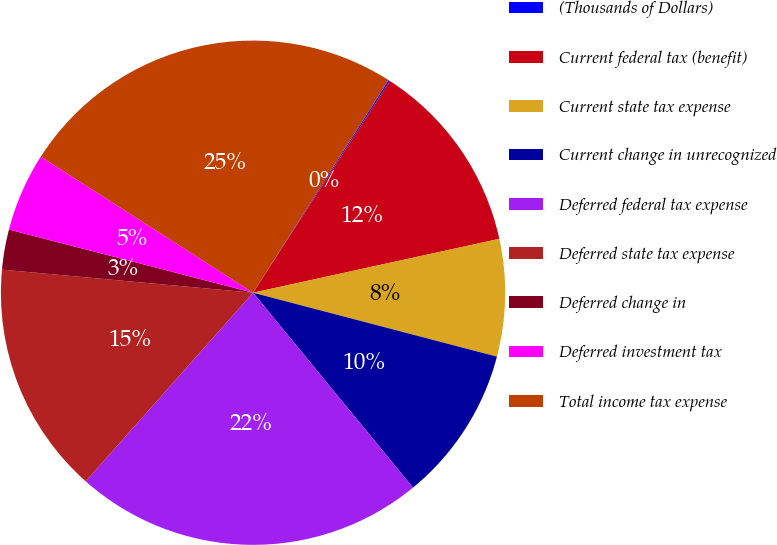<chart> <loc_0><loc_0><loc_500><loc_500><pie_chart><fcel>(Thousands of Dollars)<fcel>Current federal tax (benefit)<fcel>Current state tax expense<fcel>Current change in unrecognized<fcel>Deferred federal tax expense<fcel>Deferred state tax expense<fcel>Deferred change in<fcel>Deferred investment tax<fcel>Total income tax expense<nl><fcel>0.1%<fcel>12.44%<fcel>7.51%<fcel>9.98%<fcel>22.49%<fcel>14.91%<fcel>2.57%<fcel>5.04%<fcel>24.96%<nl></chart> 